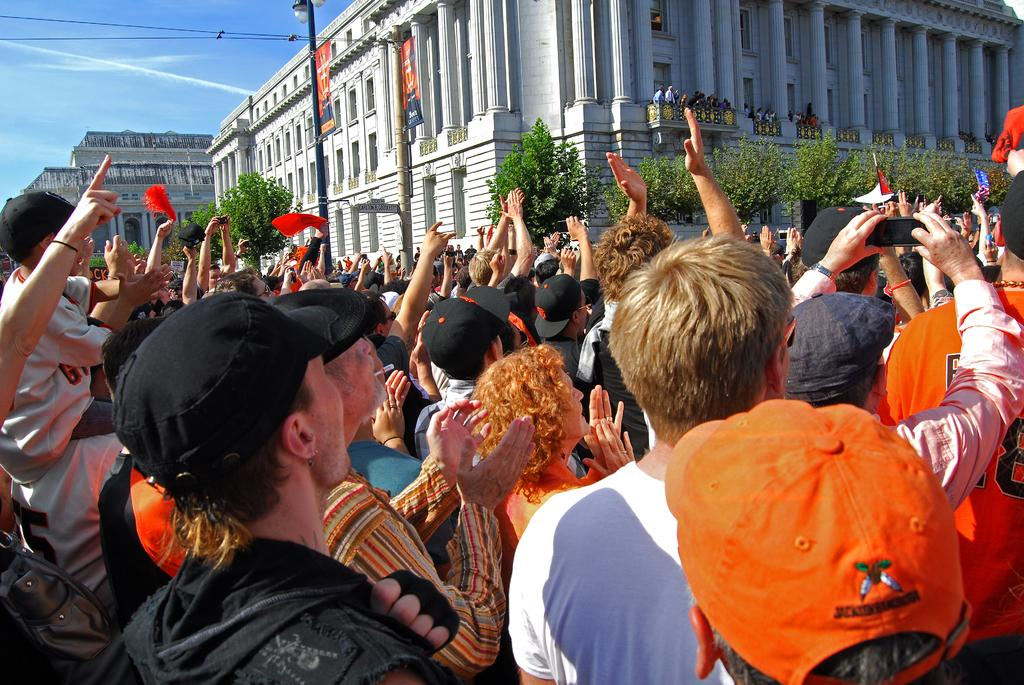What type of structures can be seen in the image? There are buildings in the image. What other natural elements are present in the image? There are trees in the image. Are there any people visible in the image? Yes, there are people standing in the image. Can you describe the clothing of some people in the image? Some people are wearing caps in the image. What type of lighting is present in the image? There is a pole light in the image. How would you describe the weather in the image? The sky is blue and cloudy in the image, suggesting a partly cloudy day. Reasoning: Let'ing: Let's think step by step in order to produce the conversation. We start by identifying the main subjects and objects in the image based on the provided facts. We then formulate questions that focus on the location and characteristics of these subjects and objects, ensuring that each question can be answered definitively with the information given. We avoid yes/no questions and ensure that the language is simple and clear. Absurd Question/Answer: Can you see an army of ants marching across the image? There is no army of ants present in the image. Is there an airplane flying in the sky in the image? The sky is visible in the image, but there is no airplane present. What type of pet can be seen playing with a ball in the image? There is no pet present in the image, and therefore no such activity can be observed. 